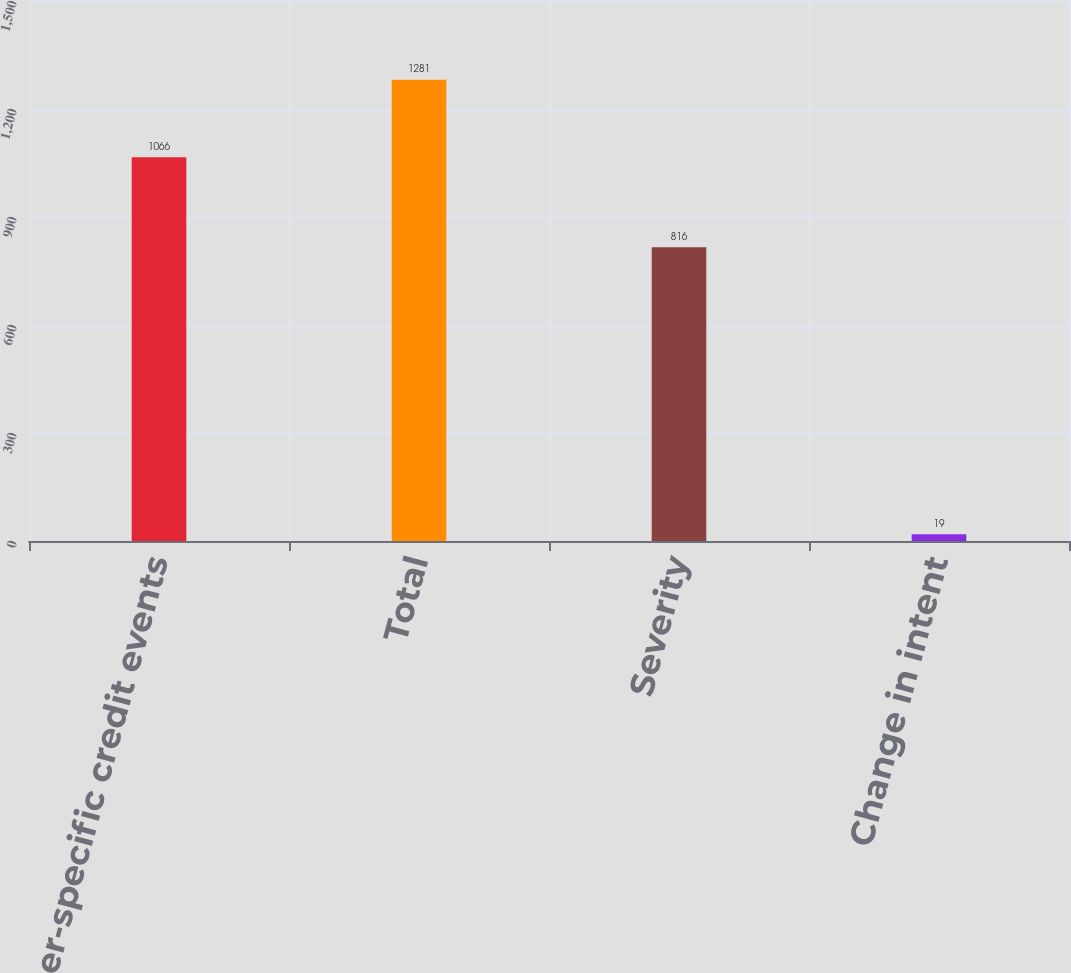Convert chart. <chart><loc_0><loc_0><loc_500><loc_500><bar_chart><fcel>Issuer-specific credit events<fcel>Total<fcel>Severity<fcel>Change in intent<nl><fcel>1066<fcel>1281<fcel>816<fcel>19<nl></chart> 